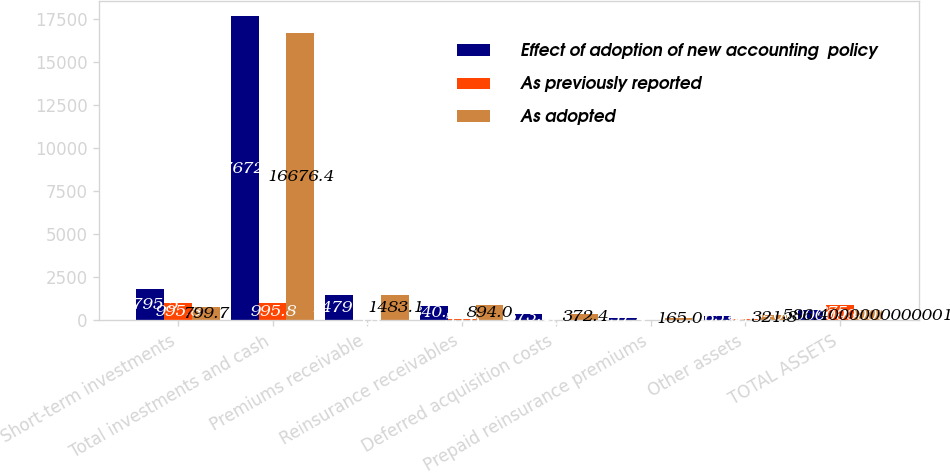Convert chart to OTSL. <chart><loc_0><loc_0><loc_500><loc_500><stacked_bar_chart><ecel><fcel>Short-term investments<fcel>Total investments and cash<fcel>Premiums receivable<fcel>Reinsurance receivables<fcel>Deferred acquisition costs<fcel>Prepaid reinsurance premiums<fcel>Other assets<fcel>TOTAL ASSETS<nl><fcel>Effect of adoption of new accounting  policy<fcel>1795.5<fcel>17672.2<fcel>1479.3<fcel>840.4<fcel>373.1<fcel>157.4<fcel>265.6<fcel>586.4<nl><fcel>As previously reported<fcel>995.8<fcel>995.8<fcel>3.8<fcel>53.6<fcel>0.7<fcel>7.5<fcel>56.2<fcel>875.3<nl><fcel>As adopted<fcel>799.7<fcel>16676.4<fcel>1483.1<fcel>894<fcel>372.4<fcel>165<fcel>321.8<fcel>586.4<nl></chart> 